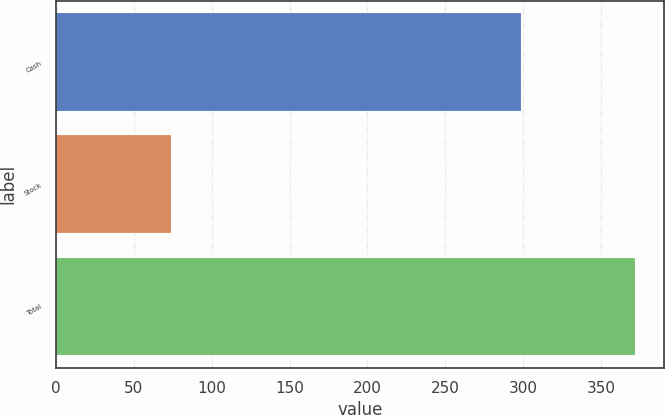Convert chart. <chart><loc_0><loc_0><loc_500><loc_500><bar_chart><fcel>Cash<fcel>Stock<fcel>Total<nl><fcel>298.4<fcel>73.6<fcel>372<nl></chart> 